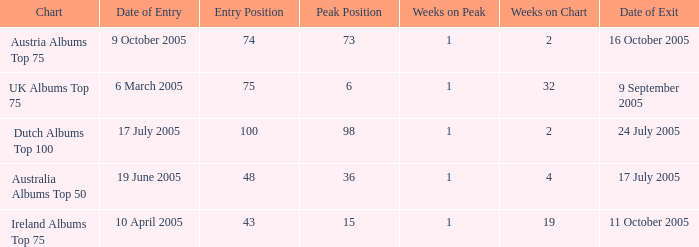What is the exit date for the Dutch Albums Top 100 Chart? 24 July 2005. 